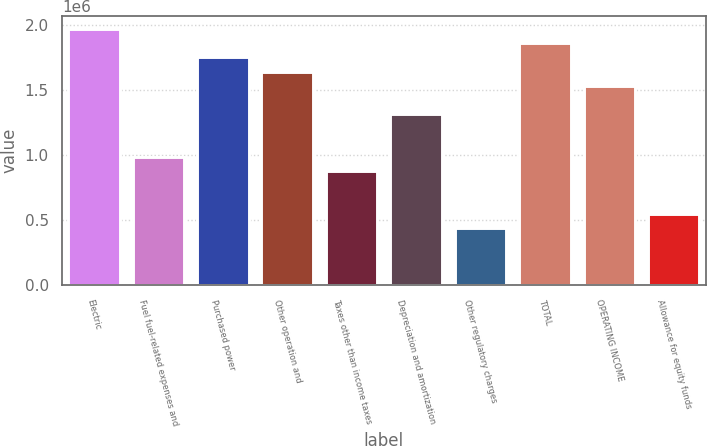<chart> <loc_0><loc_0><loc_500><loc_500><bar_chart><fcel>Electric<fcel>Fuel fuel-related expenses and<fcel>Purchased power<fcel>Other operation and<fcel>Taxes other than income taxes<fcel>Depreciation and amortization<fcel>Other regulatory charges<fcel>TOTAL<fcel>OPERATING INCOME<fcel>Allowance for equity funds<nl><fcel>1.96984e+06<fcel>985250<fcel>1.75104e+06<fcel>1.64165e+06<fcel>875850<fcel>1.31345e+06<fcel>438253<fcel>1.86044e+06<fcel>1.53225e+06<fcel>547652<nl></chart> 